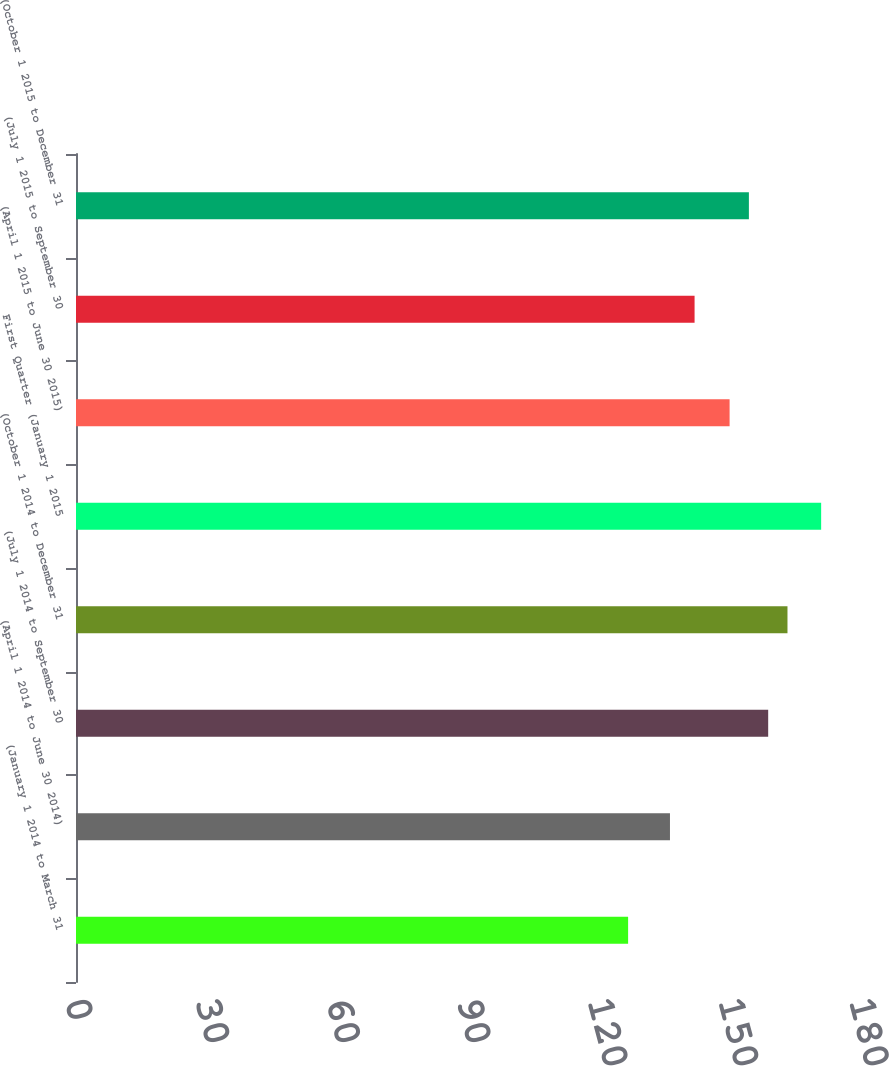Convert chart. <chart><loc_0><loc_0><loc_500><loc_500><bar_chart><fcel>(January 1 2014 to March 31<fcel>(April 1 2014 to June 30 2014)<fcel>(July 1 2014 to September 30<fcel>(October 1 2014 to December 31<fcel>First Quarter (January 1 2015<fcel>(April 1 2015 to June 30 2015)<fcel>(July 1 2015 to September 30<fcel>(October 1 2015 to December 31<nl><fcel>126.76<fcel>136.37<fcel>158.92<fcel>163.35<fcel>171.08<fcel>150.06<fcel>142.02<fcel>154.49<nl></chart> 